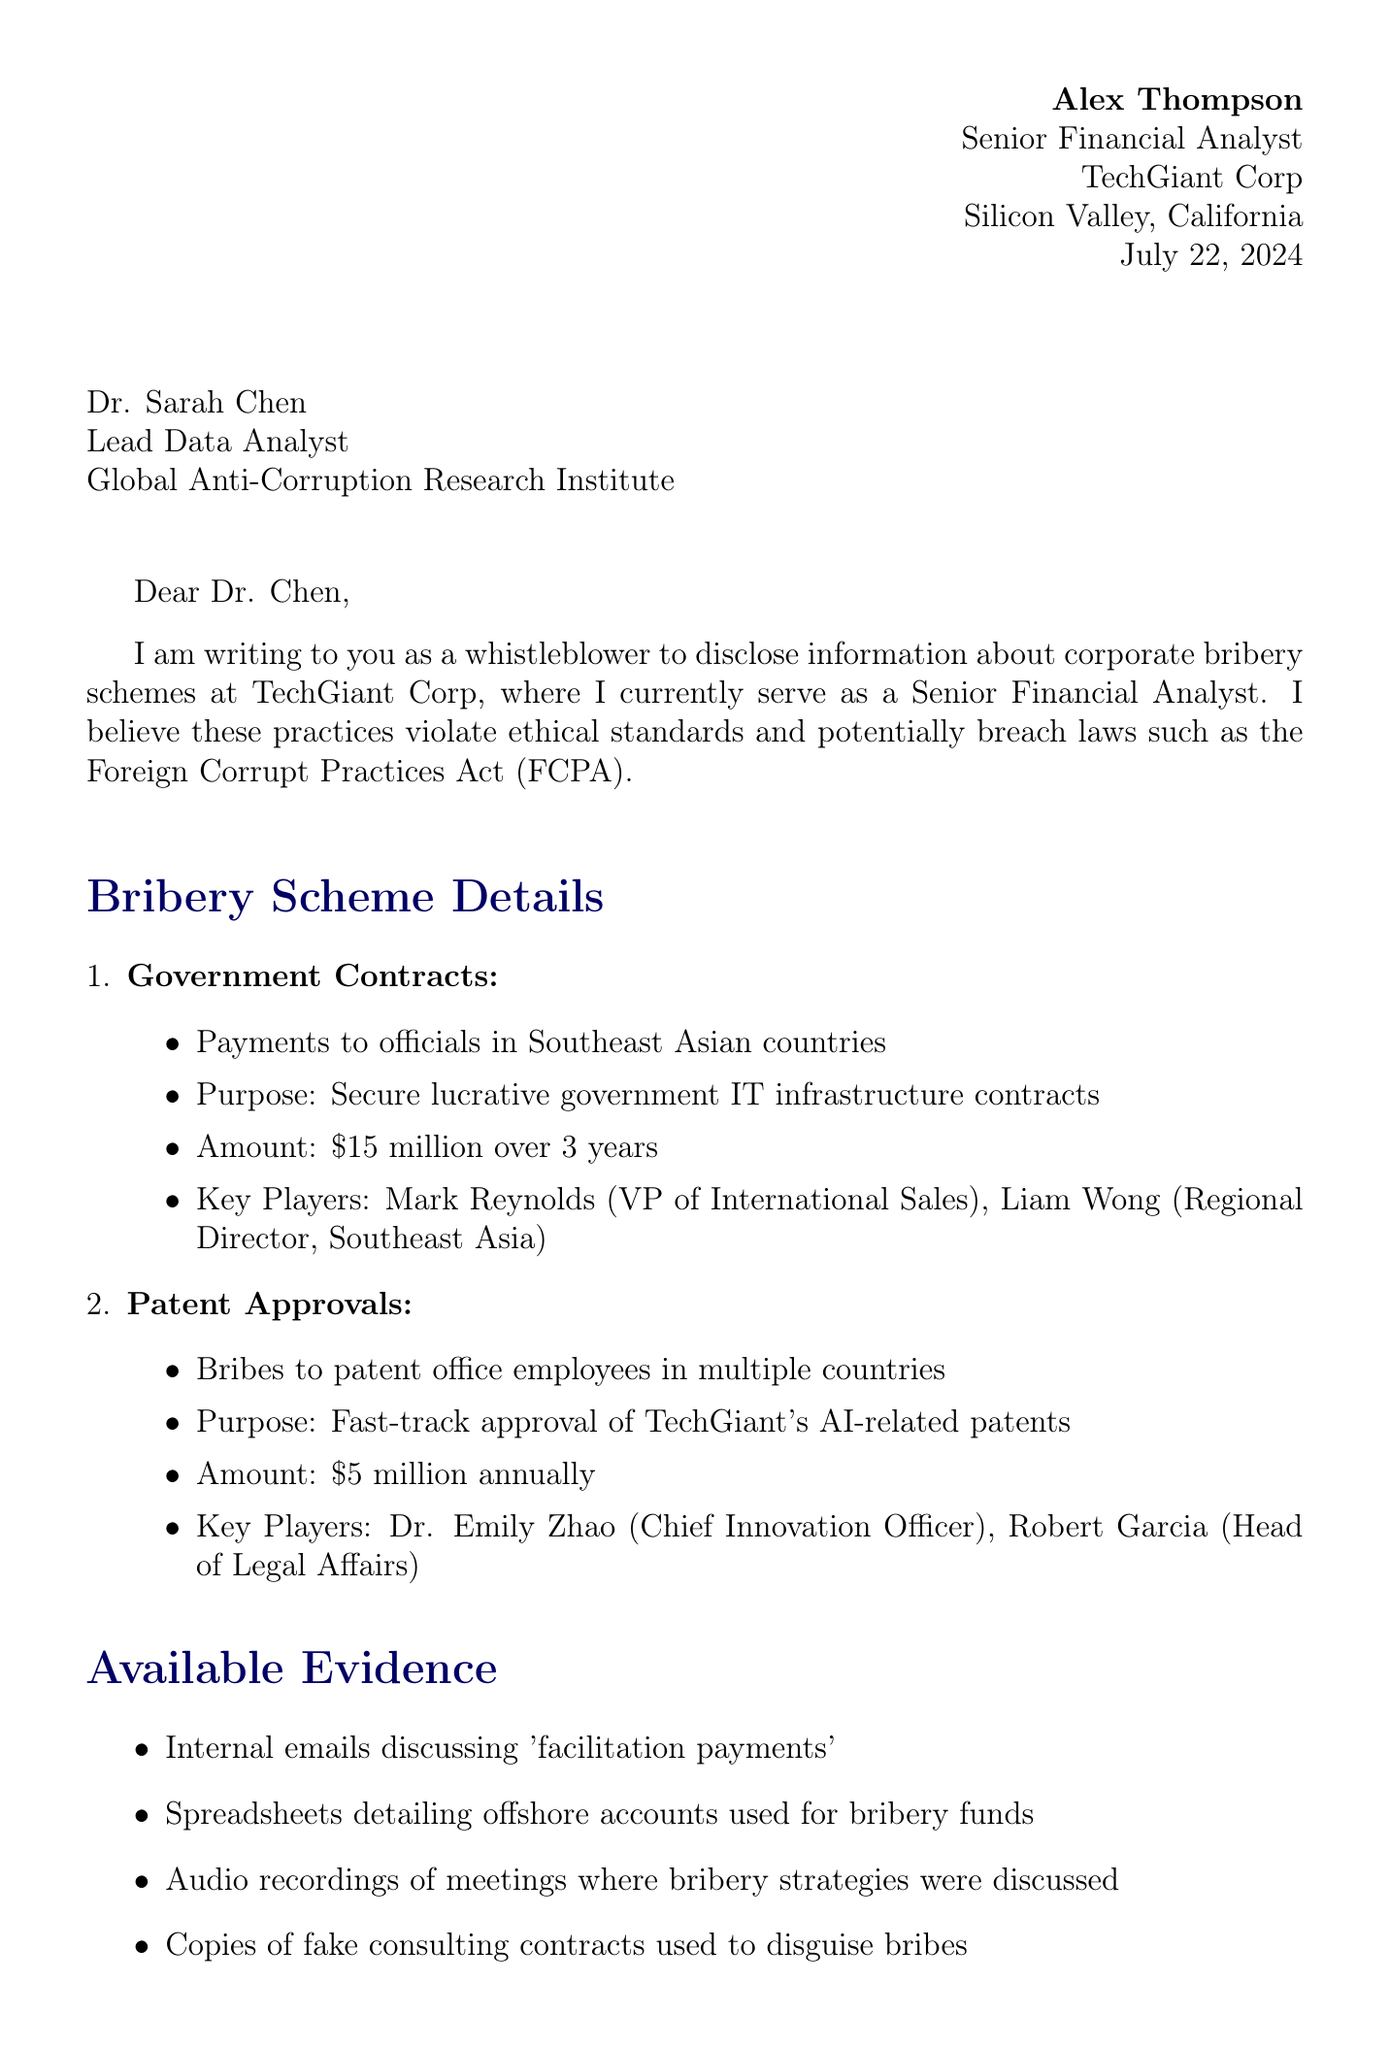What is the sender's name? The sender's name is stated at the beginning of the letter as Alex Thompson.
Answer: Alex Thompson Who is the recipient of the letter? The recipient is mentioned in the address section of the letter as Dr. Sarah Chen.
Answer: Dr. Sarah Chen What position does Alex Thompson hold? The document specifies Alex Thompson's position as Senior Financial Analyst at TechGiant Corp.
Answer: Senior Financial Analyst What is the total amount involved in government contracts bribery? The letter mentions the total amount paid for government contracts as fifteen million dollars over three years.
Answer: $15 million over 3 years Which act does the letter suggest TechGiant Corp may have violated? The letter refers to the Foreign Corrupt Practices Act in relation to the bribery schemes.
Answer: Foreign Corrupt Practices Act What is the main motivation for whistleblowing mentioned in the letter? One of the motivations outlined in the letter is ethical concerns about corporate practices.
Answer: Ethical concerns Who is listed as the Chief Innovation Officer at TechGiant Corp? The letter identifies Dr. Emily Zhao as the Chief Innovation Officer in regard to patent approval schemes.
Answer: Dr. Emily Zhao What type of evidence is available to support the claims? The letter details multiple forms of evidence, including internal emails discussing facilitation payments.
Answer: Internal emails discussing 'facilitation payments' What is the potential fine mentioned in legal consequences? The letter states that potential fines could exceed one billion dollars due to violations.
Answer: Exceeding $1 billion 